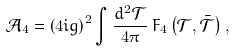Convert formula to latex. <formula><loc_0><loc_0><loc_500><loc_500>\mathcal { A } _ { 4 } = \left ( 4 i g \right ) ^ { 2 } \int \frac { d ^ { 2 } \mathcal { T } } { 4 \pi } \, F _ { 4 } \left ( \mathcal { T } , \bar { \mathcal { T } } \right ) ,</formula> 